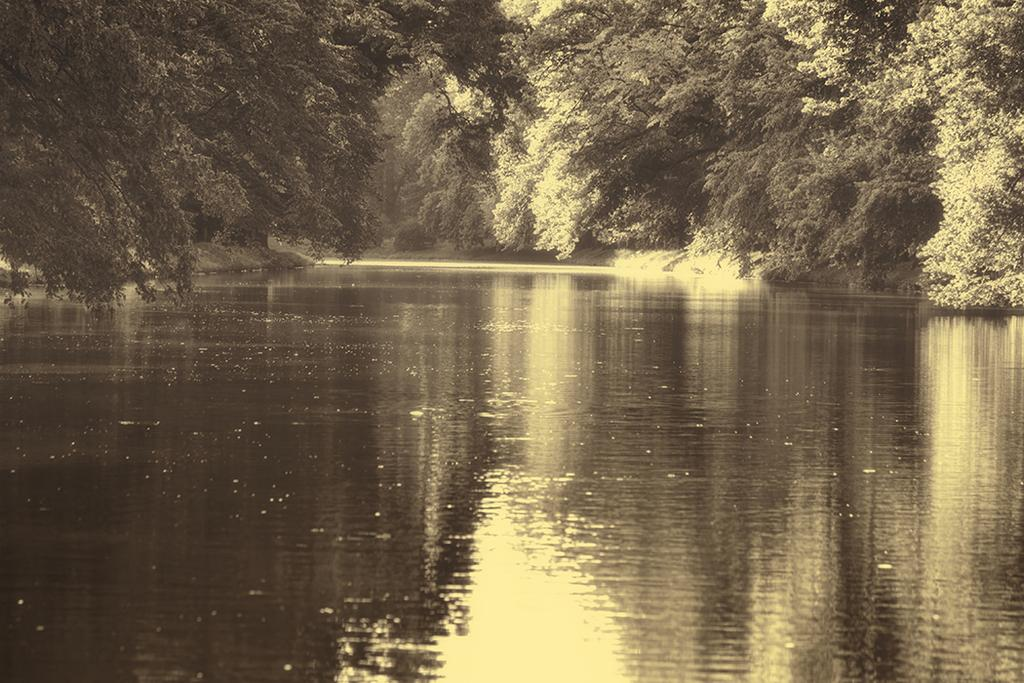What is at the bottom of the image? There is water at the bottom of the image. What can be seen on either side of the water? There are trees on either side of the water. How would you describe the style of the image? The image appears to have a vintage style. Where is the library located in the image? There is no library present in the image. What type of paste is being used to create the vintage effect in the image? The image does not depict any paste or indicate that a vintage effect was created using paste. 